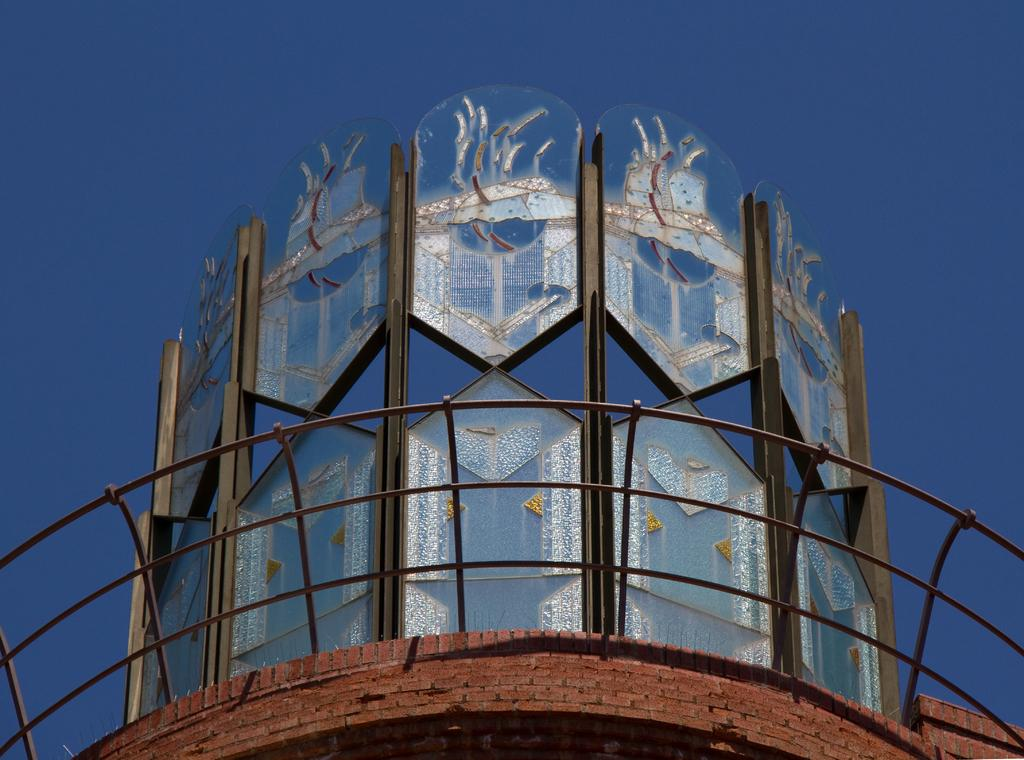What type of structure is depicted in the image? There is an architectural building in the image. What specific feature can be seen on the building? There are iron grilles in the image. What can be seen in the background of the image? The sky is visible behind the architectural building. What type of linen is being used for the event in the image? There is no event or linen present in the image; it features an architectural building with iron grilles and a visible sky. 